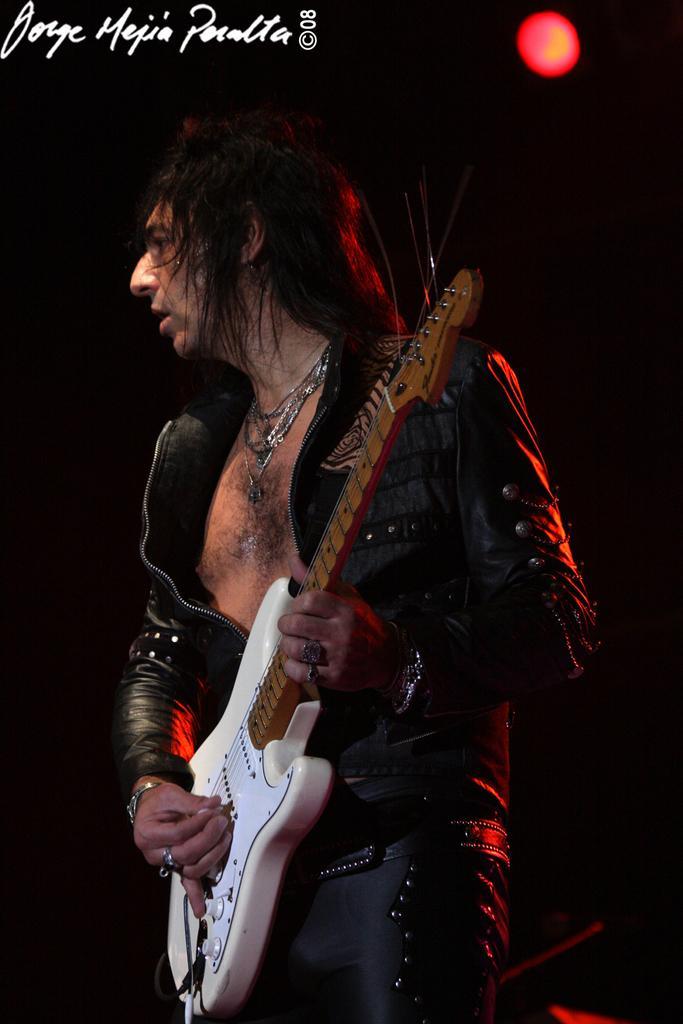Could you give a brief overview of what you see in this image? In the middle of the picture there is man ,who is playing guitar. He is wearing a black jacket ,black pant. He is wearing chains, rings in his fingers. The background is dark. There is a red light in the background. In the left top corner there is written something. 